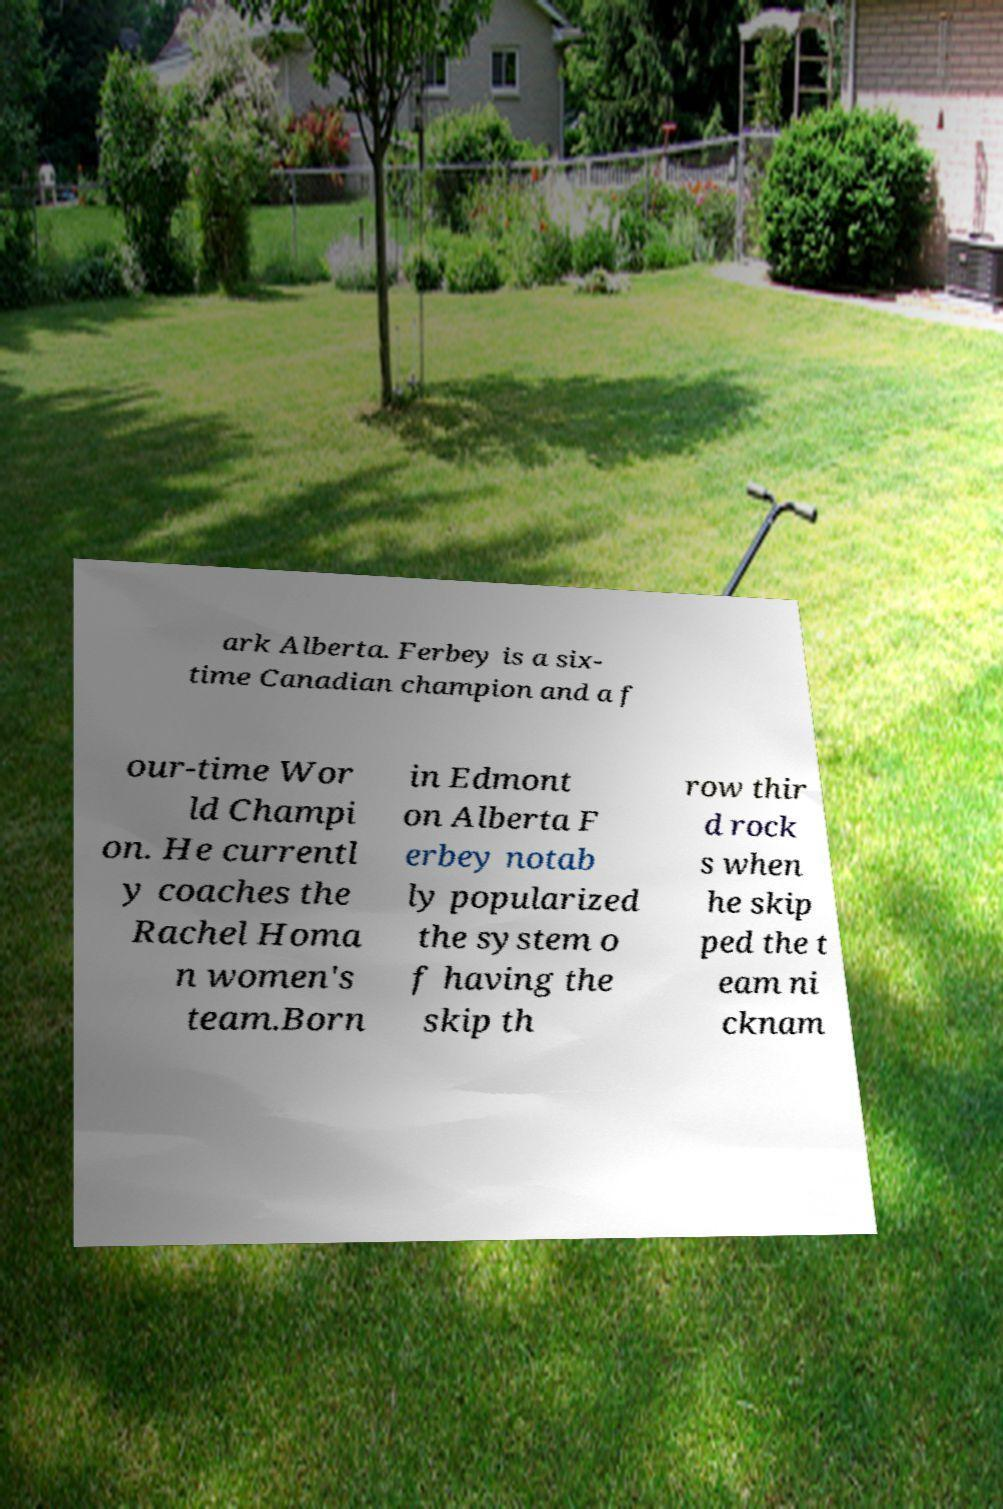Could you assist in decoding the text presented in this image and type it out clearly? ark Alberta. Ferbey is a six- time Canadian champion and a f our-time Wor ld Champi on. He currentl y coaches the Rachel Homa n women's team.Born in Edmont on Alberta F erbey notab ly popularized the system o f having the skip th row thir d rock s when he skip ped the t eam ni cknam 